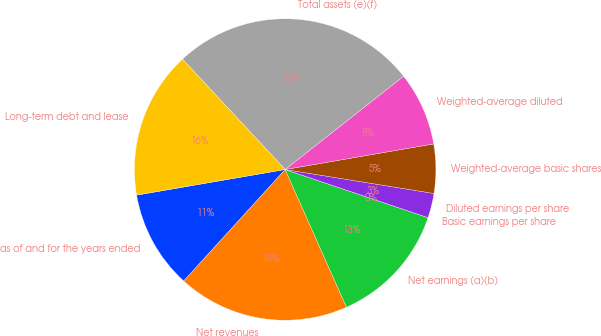Convert chart. <chart><loc_0><loc_0><loc_500><loc_500><pie_chart><fcel>as of and for the years ended<fcel>Net revenues<fcel>Net earnings (a)(b)<fcel>Basic earnings per share<fcel>Diluted earnings per share<fcel>Weighted-average basic shares<fcel>Weighted-average diluted<fcel>Total assets (e)(f)<fcel>Long-term debt and lease<nl><fcel>10.53%<fcel>18.42%<fcel>13.16%<fcel>0.0%<fcel>2.63%<fcel>5.26%<fcel>7.9%<fcel>26.31%<fcel>15.79%<nl></chart> 